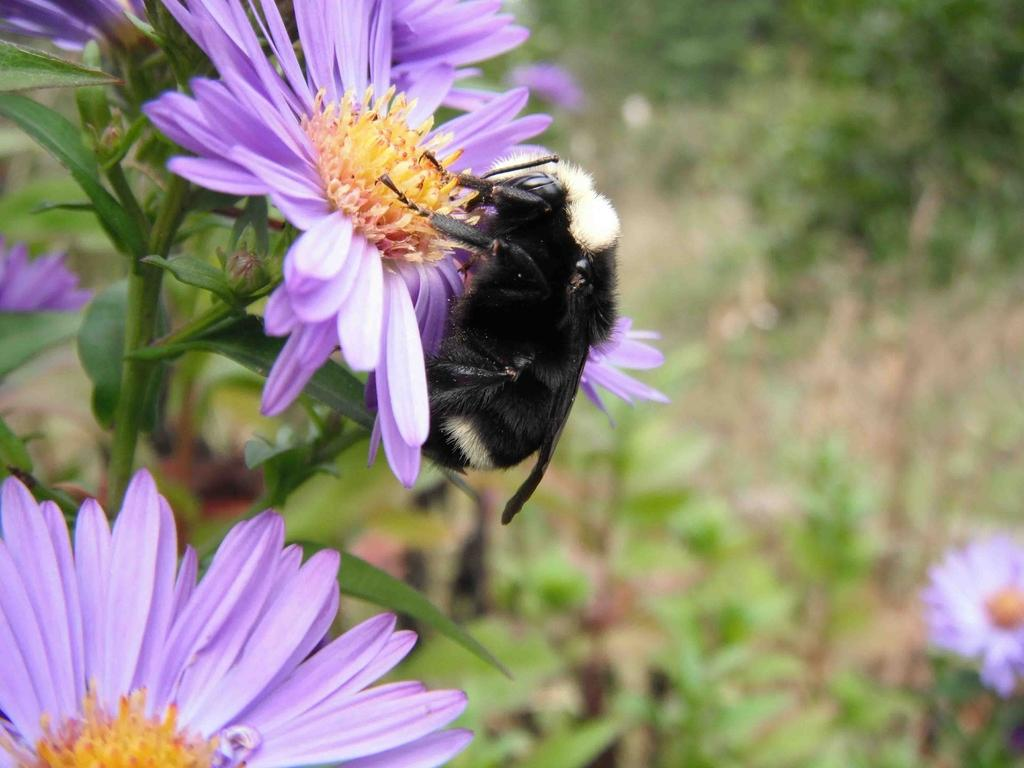What type of living organism can be seen in the image? There is an insect in the image. What other natural elements are present in the image? There are plants and flowers in the image. How would you describe the background of the image? The background of the image is blurred. Where is the lunchroom located in the image? There is no lunchroom present in the image. Are there any bears visible in the image? There are no bears present in the image. 